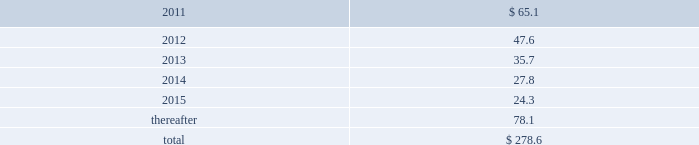Future minimum operating lease payments for leases with remaining terms greater than one year for each of the years in the five years ending december 31 , 2015 , and thereafter in the aggregate , are as follows ( in millions ) : .
In addition , the company has operating lease commitments relating to office equipment and computer hardware with annual lease payments of approximately $ 16.3 million per year which renew on a short-term basis .
Rent expense incurred under all operating leases during the years ended december 31 , 2010 , 2009 and 2008 was $ 116.1 million , $ 100.2 million and $ 117.0 million , respectively .
Included in discontinued operations in the consolidated statements of earnings was rent expense of $ 2.0 million , $ 1.8 million and $ 17.0 million for the years ended december 31 , 2010 , 2009 and 2008 , respectively .
Data processing and maintenance services agreements .
The company has agreements with various vendors , which expire between 2011 and 2017 , for portions of its computer data processing operations and related functions .
The company 2019s estimated aggregate contractual obligation remaining under these agreements was approximately $ 554.3 million as of december 31 , 2010 .
However , this amount could be more or less depending on various factors such as the inflation rate , foreign exchange rates , the introduction of significant new technologies , or changes in the company 2019s data processing needs .
( 16 ) employee benefit plans stock purchase plan fis employees participate in an employee stock purchase plan ( espp ) .
Eligible employees may voluntarily purchase , at current market prices , shares of fis 2019 common stock through payroll deductions .
Pursuant to the espp , employees may contribute an amount between 3% ( 3 % ) and 15% ( 15 % ) of their base salary and certain commissions .
Shares purchased are allocated to employees based upon their contributions .
The company contributes varying matching amounts as specified in the espp .
The company recorded an expense of $ 14.3 million , $ 12.4 million and $ 14.3 million , respectively , for the years ended december 31 , 2010 , 2009 and 2008 , relating to the participation of fis employees in the espp .
Included in discontinued operations in the consolidated statements of earnings was expense of $ 0.1 million and $ 3.0 million for the years ended december 31 , 2009 and 2008 , respectively .
401 ( k ) profit sharing plan the company 2019s employees are covered by a qualified 401 ( k ) plan .
Eligible employees may contribute up to 40% ( 40 % ) of their pretax annual compensation , up to the amount allowed pursuant to the internal revenue code .
The company generally matches 50% ( 50 % ) of each dollar of employee contribution up to 6% ( 6 % ) of the employee 2019s total eligible compensation .
The company recorded expense of $ 23.1 million , $ 16.6 million and $ 18.5 million , respectively , for the years ended december 31 , 2010 , 2009 and 2008 , relating to the participation of fis employees in the 401 ( k ) plan .
Included in discontinued operations in the consolidated statements of earnings was expense of $ 0.1 million and $ 3.9 million for the years ended december 31 , 2009 and 2008 , respectively .
Fidelity national information services , inc .
And subsidiaries notes to consolidated financial statements 2014 ( continued ) %%transmsg*** transmitting job : g26369 pcn : 083000000 ***%%pcmsg|83 |00006|yes|no|03/28/2011 17:32|0|0|page is valid , no graphics -- color : n| .
What percentage of future minimum operating lease payments for leases with remaining terms greater than one year for each of the years in the five years ending december 31 , 2015 , and thereafter are due in 2012? 
Computations: (47.6 / 278.6)
Answer: 0.17085. Future minimum operating lease payments for leases with remaining terms greater than one year for each of the years in the five years ending december 31 , 2015 , and thereafter in the aggregate , are as follows ( in millions ) : .
In addition , the company has operating lease commitments relating to office equipment and computer hardware with annual lease payments of approximately $ 16.3 million per year which renew on a short-term basis .
Rent expense incurred under all operating leases during the years ended december 31 , 2010 , 2009 and 2008 was $ 116.1 million , $ 100.2 million and $ 117.0 million , respectively .
Included in discontinued operations in the consolidated statements of earnings was rent expense of $ 2.0 million , $ 1.8 million and $ 17.0 million for the years ended december 31 , 2010 , 2009 and 2008 , respectively .
Data processing and maintenance services agreements .
The company has agreements with various vendors , which expire between 2011 and 2017 , for portions of its computer data processing operations and related functions .
The company 2019s estimated aggregate contractual obligation remaining under these agreements was approximately $ 554.3 million as of december 31 , 2010 .
However , this amount could be more or less depending on various factors such as the inflation rate , foreign exchange rates , the introduction of significant new technologies , or changes in the company 2019s data processing needs .
( 16 ) employee benefit plans stock purchase plan fis employees participate in an employee stock purchase plan ( espp ) .
Eligible employees may voluntarily purchase , at current market prices , shares of fis 2019 common stock through payroll deductions .
Pursuant to the espp , employees may contribute an amount between 3% ( 3 % ) and 15% ( 15 % ) of their base salary and certain commissions .
Shares purchased are allocated to employees based upon their contributions .
The company contributes varying matching amounts as specified in the espp .
The company recorded an expense of $ 14.3 million , $ 12.4 million and $ 14.3 million , respectively , for the years ended december 31 , 2010 , 2009 and 2008 , relating to the participation of fis employees in the espp .
Included in discontinued operations in the consolidated statements of earnings was expense of $ 0.1 million and $ 3.0 million for the years ended december 31 , 2009 and 2008 , respectively .
401 ( k ) profit sharing plan the company 2019s employees are covered by a qualified 401 ( k ) plan .
Eligible employees may contribute up to 40% ( 40 % ) of their pretax annual compensation , up to the amount allowed pursuant to the internal revenue code .
The company generally matches 50% ( 50 % ) of each dollar of employee contribution up to 6% ( 6 % ) of the employee 2019s total eligible compensation .
The company recorded expense of $ 23.1 million , $ 16.6 million and $ 18.5 million , respectively , for the years ended december 31 , 2010 , 2009 and 2008 , relating to the participation of fis employees in the 401 ( k ) plan .
Included in discontinued operations in the consolidated statements of earnings was expense of $ 0.1 million and $ 3.9 million for the years ended december 31 , 2009 and 2008 , respectively .
Fidelity national information services , inc .
And subsidiaries notes to consolidated financial statements 2014 ( continued ) %%transmsg*** transmitting job : g26369 pcn : 083000000 ***%%pcmsg|83 |00006|yes|no|03/28/2011 17:32|0|0|page is valid , no graphics -- color : n| .
What percentage of future minimum operating lease payments for leases with remaining terms greater than one year for each of the years in the five years ending december 31 , 2015 , and thereafter are due in 2013? 
Computations: (35.7 / 278.6)
Answer: 0.12814. Future minimum operating lease payments for leases with remaining terms greater than one year for each of the years in the five years ending december 31 , 2015 , and thereafter in the aggregate , are as follows ( in millions ) : .
In addition , the company has operating lease commitments relating to office equipment and computer hardware with annual lease payments of approximately $ 16.3 million per year which renew on a short-term basis .
Rent expense incurred under all operating leases during the years ended december 31 , 2010 , 2009 and 2008 was $ 116.1 million , $ 100.2 million and $ 117.0 million , respectively .
Included in discontinued operations in the consolidated statements of earnings was rent expense of $ 2.0 million , $ 1.8 million and $ 17.0 million for the years ended december 31 , 2010 , 2009 and 2008 , respectively .
Data processing and maintenance services agreements .
The company has agreements with various vendors , which expire between 2011 and 2017 , for portions of its computer data processing operations and related functions .
The company 2019s estimated aggregate contractual obligation remaining under these agreements was approximately $ 554.3 million as of december 31 , 2010 .
However , this amount could be more or less depending on various factors such as the inflation rate , foreign exchange rates , the introduction of significant new technologies , or changes in the company 2019s data processing needs .
( 16 ) employee benefit plans stock purchase plan fis employees participate in an employee stock purchase plan ( espp ) .
Eligible employees may voluntarily purchase , at current market prices , shares of fis 2019 common stock through payroll deductions .
Pursuant to the espp , employees may contribute an amount between 3% ( 3 % ) and 15% ( 15 % ) of their base salary and certain commissions .
Shares purchased are allocated to employees based upon their contributions .
The company contributes varying matching amounts as specified in the espp .
The company recorded an expense of $ 14.3 million , $ 12.4 million and $ 14.3 million , respectively , for the years ended december 31 , 2010 , 2009 and 2008 , relating to the participation of fis employees in the espp .
Included in discontinued operations in the consolidated statements of earnings was expense of $ 0.1 million and $ 3.0 million for the years ended december 31 , 2009 and 2008 , respectively .
401 ( k ) profit sharing plan the company 2019s employees are covered by a qualified 401 ( k ) plan .
Eligible employees may contribute up to 40% ( 40 % ) of their pretax annual compensation , up to the amount allowed pursuant to the internal revenue code .
The company generally matches 50% ( 50 % ) of each dollar of employee contribution up to 6% ( 6 % ) of the employee 2019s total eligible compensation .
The company recorded expense of $ 23.1 million , $ 16.6 million and $ 18.5 million , respectively , for the years ended december 31 , 2010 , 2009 and 2008 , relating to the participation of fis employees in the 401 ( k ) plan .
Included in discontinued operations in the consolidated statements of earnings was expense of $ 0.1 million and $ 3.9 million for the years ended december 31 , 2009 and 2008 , respectively .
Fidelity national information services , inc .
And subsidiaries notes to consolidated financial statements 2014 ( continued ) %%transmsg*** transmitting job : g26369 pcn : 083000000 ***%%pcmsg|83 |00006|yes|no|03/28/2011 17:32|0|0|page is valid , no graphics -- color : n| .
What is the increase in rent expense from 2008 to 2009? 
Computations: ((100.2 - 117.0) / 117.0)
Answer: -0.14359. 